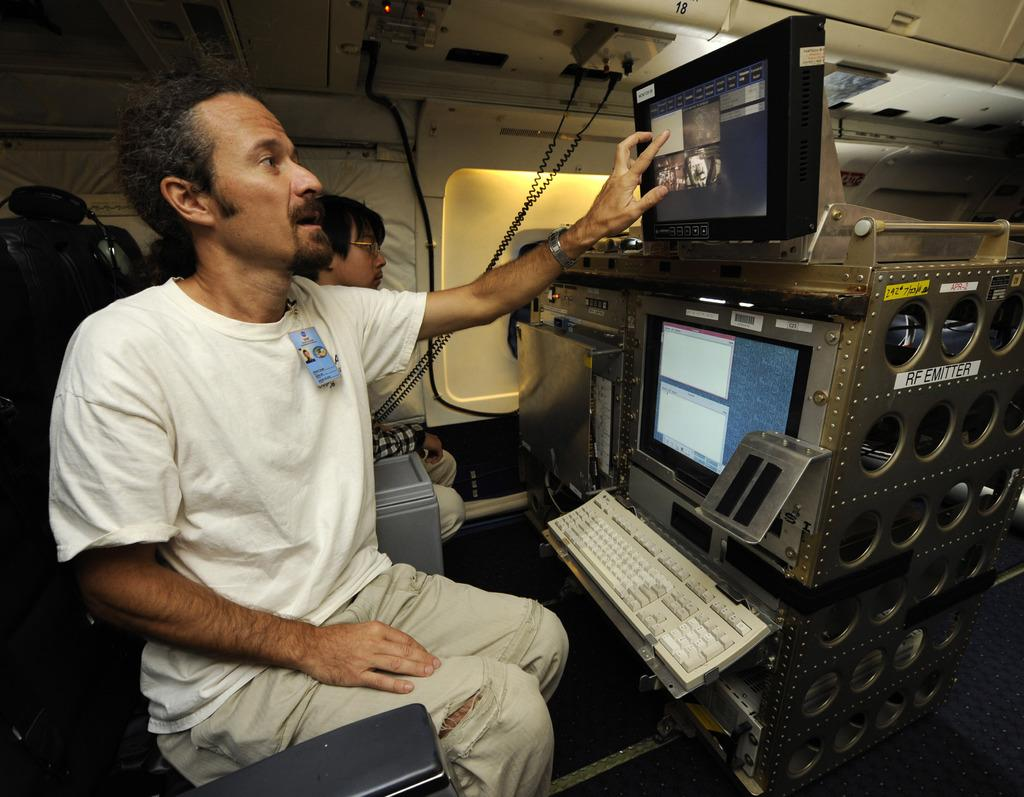<image>
Provide a brief description of the given image. The RF Emitter looks like a complicated piece of flight equiment, requiring the trained operator, which is touching the top monitor, to understand the software 